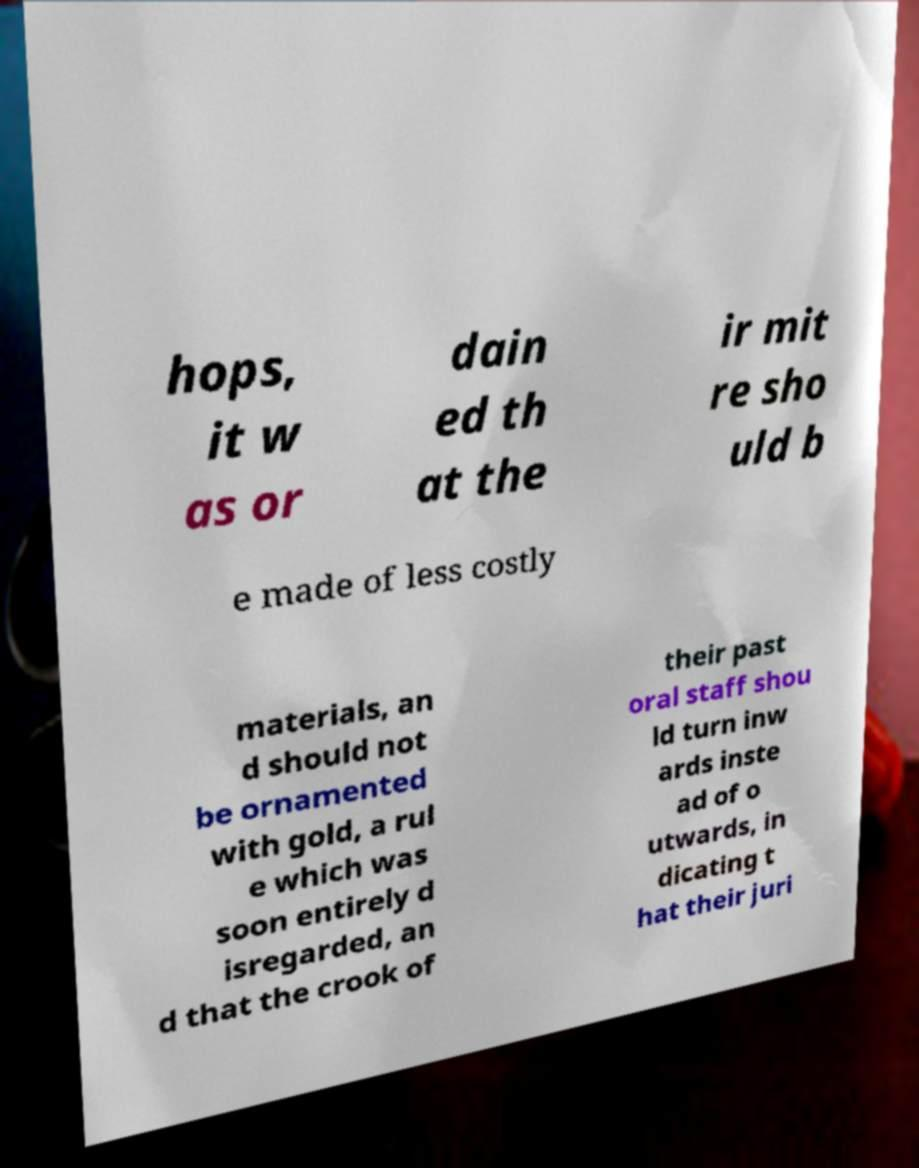Could you extract and type out the text from this image? hops, it w as or dain ed th at the ir mit re sho uld b e made of less costly materials, an d should not be ornamented with gold, a rul e which was soon entirely d isregarded, an d that the crook of their past oral staff shou ld turn inw ards inste ad of o utwards, in dicating t hat their juri 